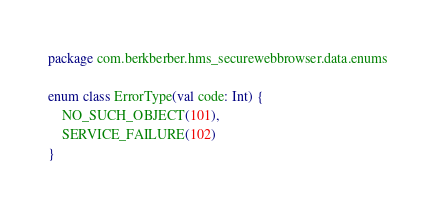Convert code to text. <code><loc_0><loc_0><loc_500><loc_500><_Kotlin_>package com.berkberber.hms_securewebbrowser.data.enums

enum class ErrorType(val code: Int) {
    NO_SUCH_OBJECT(101),
    SERVICE_FAILURE(102)
}</code> 